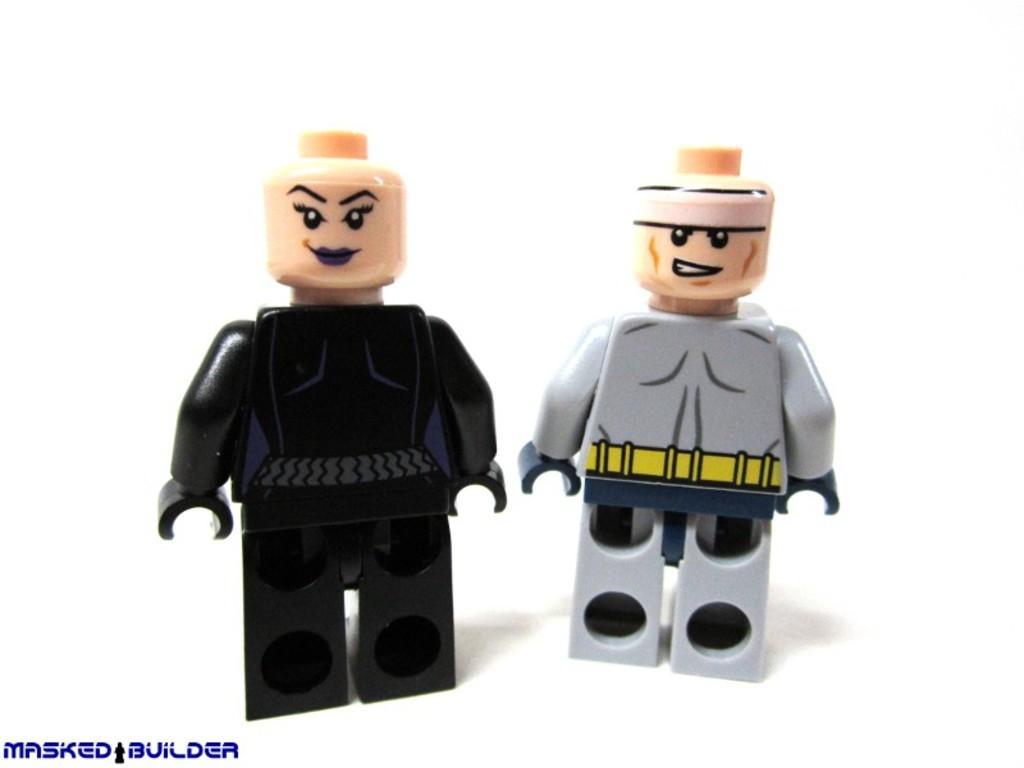How would you summarize this image in a sentence or two? In the picture we can see two men dolls and one is black in color, dress and one doll is gray in color dress. 